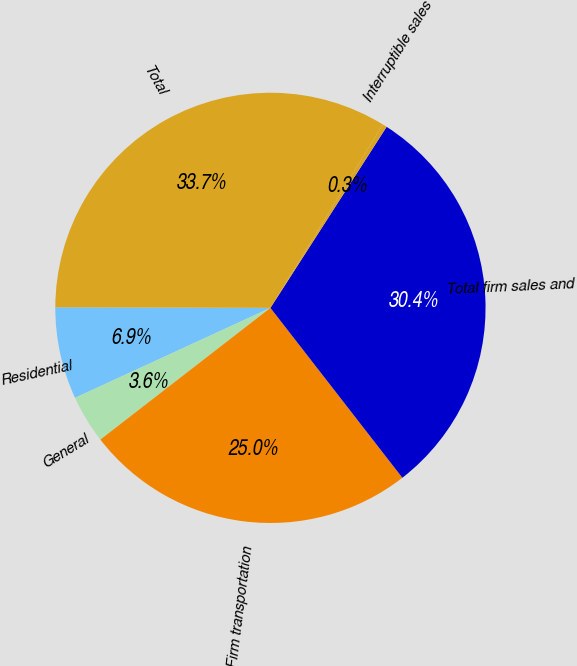Convert chart. <chart><loc_0><loc_0><loc_500><loc_500><pie_chart><fcel>Residential<fcel>General<fcel>Firm transportation<fcel>Total firm sales and<fcel>Interruptible sales<fcel>Total<nl><fcel>6.91%<fcel>3.62%<fcel>25.02%<fcel>30.41%<fcel>0.33%<fcel>33.71%<nl></chart> 